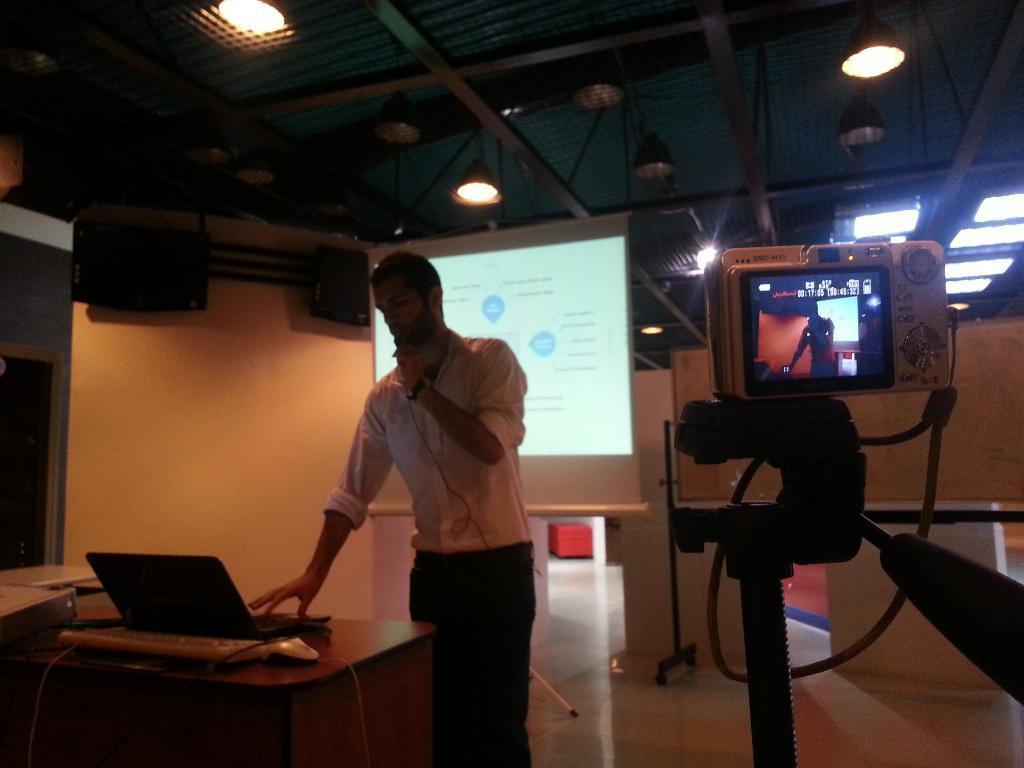Can you describe this image briefly? In the center of the image there is a man standing. There is a table placed before him. There is a laptop, keyboard, mouse placed on the table. In the background there is a screen. on the right there is a camera. At the top there are lights. 